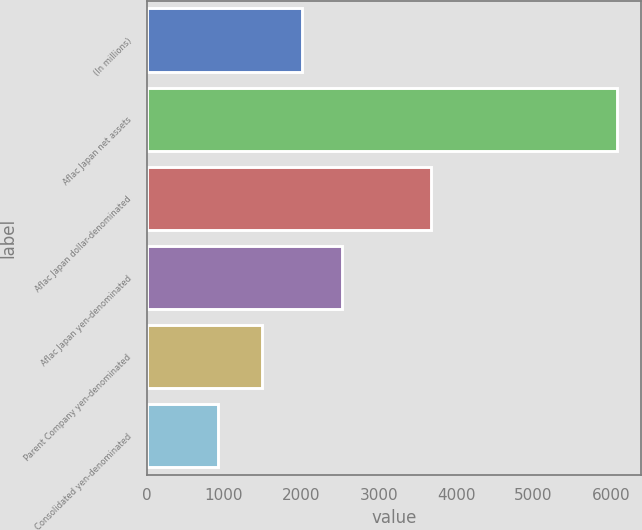<chart> <loc_0><loc_0><loc_500><loc_500><bar_chart><fcel>(In millions)<fcel>Aflac Japan net assets<fcel>Aflac Japan dollar-denominated<fcel>Aflac Japan yen-denominated<fcel>Parent Company yen-denominated<fcel>Consolidated yen-denominated<nl><fcel>2012.8<fcel>6087<fcel>3672<fcel>2529.6<fcel>1496<fcel>919<nl></chart> 